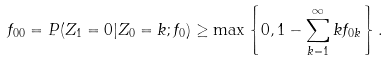Convert formula to latex. <formula><loc_0><loc_0><loc_500><loc_500>f _ { 0 0 } = P ( Z _ { 1 } = 0 | Z _ { 0 } = k ; f _ { 0 } ) \geq \max \left \{ 0 , 1 - \sum _ { k = 1 } ^ { \infty } k f _ { 0 k } \right \} .</formula> 